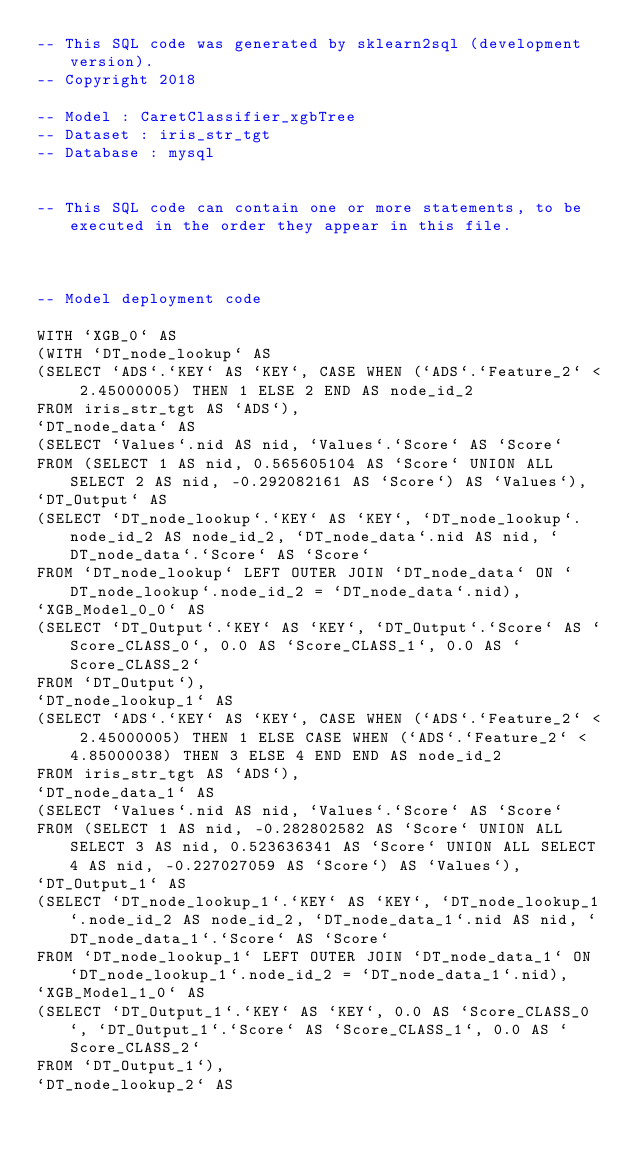<code> <loc_0><loc_0><loc_500><loc_500><_SQL_>-- This SQL code was generated by sklearn2sql (development version).
-- Copyright 2018

-- Model : CaretClassifier_xgbTree
-- Dataset : iris_str_tgt
-- Database : mysql


-- This SQL code can contain one or more statements, to be executed in the order they appear in this file.



-- Model deployment code

WITH `XGB_0` AS 
(WITH `DT_node_lookup` AS 
(SELECT `ADS`.`KEY` AS `KEY`, CASE WHEN (`ADS`.`Feature_2` < 2.45000005) THEN 1 ELSE 2 END AS node_id_2 
FROM iris_str_tgt AS `ADS`), 
`DT_node_data` AS 
(SELECT `Values`.nid AS nid, `Values`.`Score` AS `Score` 
FROM (SELECT 1 AS nid, 0.565605104 AS `Score` UNION ALL SELECT 2 AS nid, -0.292082161 AS `Score`) AS `Values`), 
`DT_Output` AS 
(SELECT `DT_node_lookup`.`KEY` AS `KEY`, `DT_node_lookup`.node_id_2 AS node_id_2, `DT_node_data`.nid AS nid, `DT_node_data`.`Score` AS `Score` 
FROM `DT_node_lookup` LEFT OUTER JOIN `DT_node_data` ON `DT_node_lookup`.node_id_2 = `DT_node_data`.nid), 
`XGB_Model_0_0` AS 
(SELECT `DT_Output`.`KEY` AS `KEY`, `DT_Output`.`Score` AS `Score_CLASS_0`, 0.0 AS `Score_CLASS_1`, 0.0 AS `Score_CLASS_2` 
FROM `DT_Output`), 
`DT_node_lookup_1` AS 
(SELECT `ADS`.`KEY` AS `KEY`, CASE WHEN (`ADS`.`Feature_2` < 2.45000005) THEN 1 ELSE CASE WHEN (`ADS`.`Feature_2` < 4.85000038) THEN 3 ELSE 4 END END AS node_id_2 
FROM iris_str_tgt AS `ADS`), 
`DT_node_data_1` AS 
(SELECT `Values`.nid AS nid, `Values`.`Score` AS `Score` 
FROM (SELECT 1 AS nid, -0.282802582 AS `Score` UNION ALL SELECT 3 AS nid, 0.523636341 AS `Score` UNION ALL SELECT 4 AS nid, -0.227027059 AS `Score`) AS `Values`), 
`DT_Output_1` AS 
(SELECT `DT_node_lookup_1`.`KEY` AS `KEY`, `DT_node_lookup_1`.node_id_2 AS node_id_2, `DT_node_data_1`.nid AS nid, `DT_node_data_1`.`Score` AS `Score` 
FROM `DT_node_lookup_1` LEFT OUTER JOIN `DT_node_data_1` ON `DT_node_lookup_1`.node_id_2 = `DT_node_data_1`.nid), 
`XGB_Model_1_0` AS 
(SELECT `DT_Output_1`.`KEY` AS `KEY`, 0.0 AS `Score_CLASS_0`, `DT_Output_1`.`Score` AS `Score_CLASS_1`, 0.0 AS `Score_CLASS_2` 
FROM `DT_Output_1`), 
`DT_node_lookup_2` AS </code> 